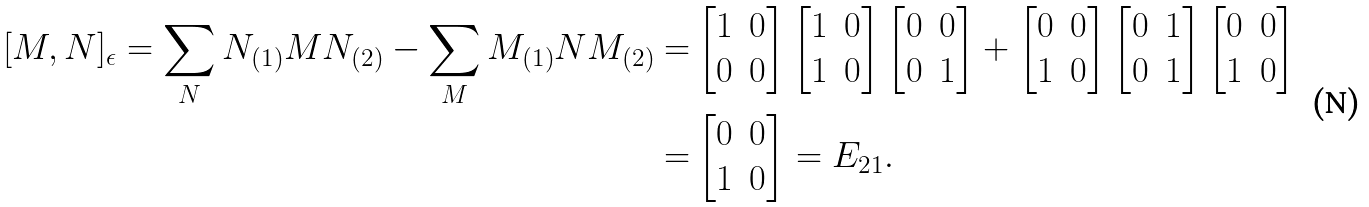Convert formula to latex. <formula><loc_0><loc_0><loc_500><loc_500>[ M , N ] _ { \epsilon } = \sum _ { N } N _ { ( 1 ) } M N _ { ( 2 ) } - \sum _ { M } M _ { ( 1 ) } N M _ { ( 2 ) } = & \begin{bmatrix} 1 & 0 \\ 0 & 0 \end{bmatrix} \begin{bmatrix} 1 & 0 \\ 1 & 0 \end{bmatrix} \begin{bmatrix} 0 & 0 \\ 0 & 1 \end{bmatrix} + \begin{bmatrix} 0 & 0 \\ 1 & 0 \end{bmatrix} \begin{bmatrix} 0 & 1 \\ 0 & 1 \end{bmatrix} \begin{bmatrix} 0 & 0 \\ 1 & 0 \end{bmatrix} \\ = & \begin{bmatrix} 0 & 0 \\ 1 & 0 \end{bmatrix} = E _ { 2 1 } .</formula> 